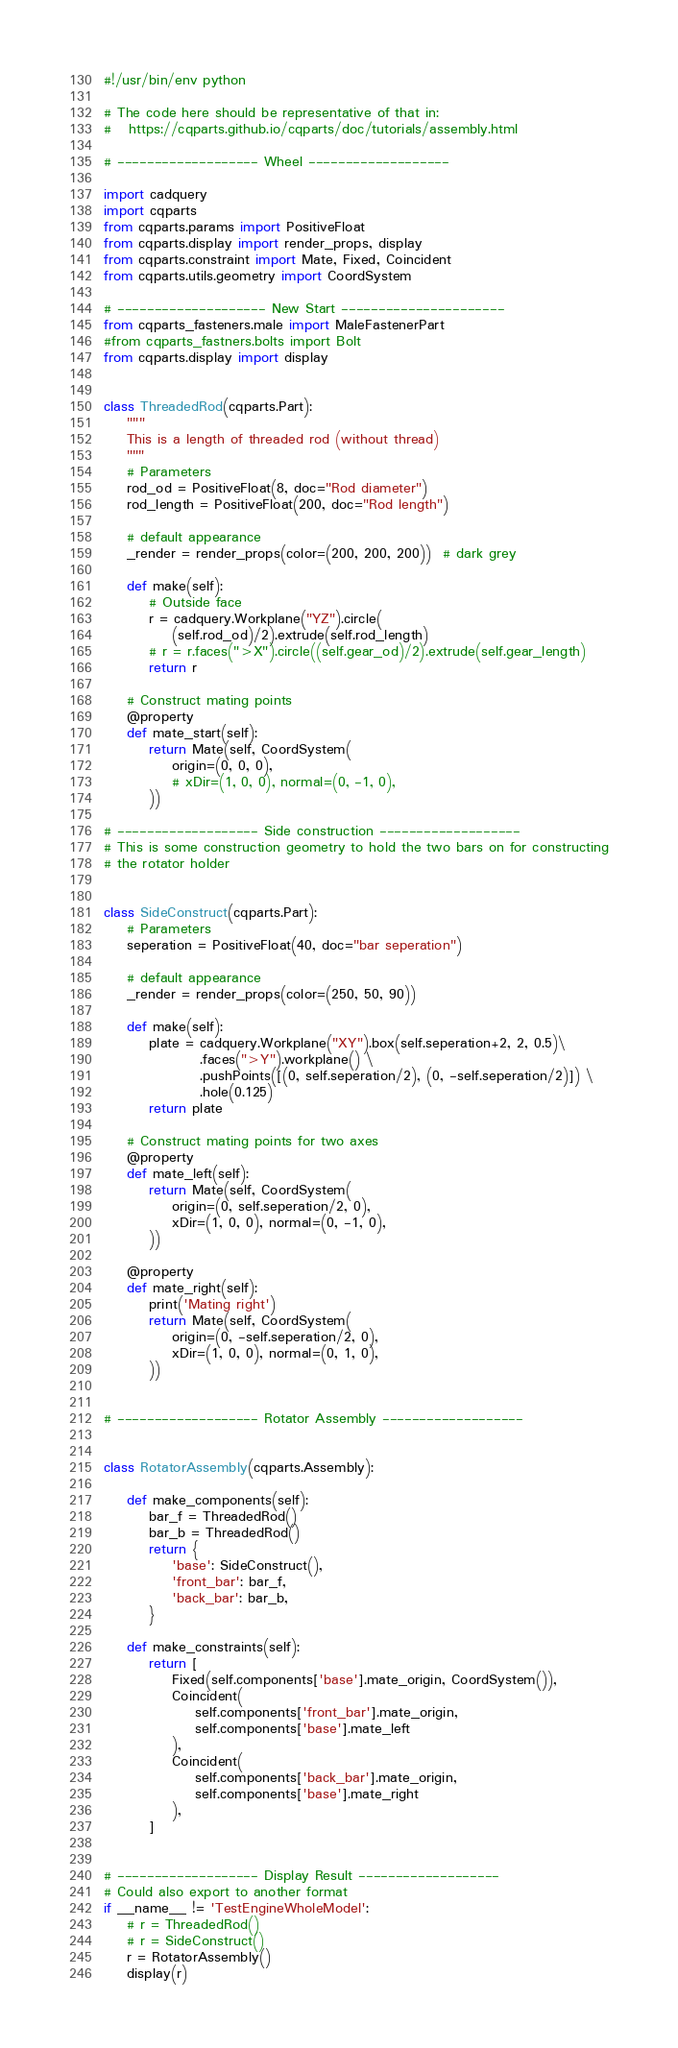Convert code to text. <code><loc_0><loc_0><loc_500><loc_500><_Python_>#!/usr/bin/env python

# The code here should be representative of that in:
#   https://cqparts.github.io/cqparts/doc/tutorials/assembly.html

# ------------------- Wheel -------------------

import cadquery
import cqparts
from cqparts.params import PositiveFloat
from cqparts.display import render_props, display
from cqparts.constraint import Mate, Fixed, Coincident
from cqparts.utils.geometry import CoordSystem

# -------------------- New Start ----------------------
from cqparts_fasteners.male import MaleFastenerPart
#from cqparts_fastners.bolts import Bolt
from cqparts.display import display


class ThreadedRod(cqparts.Part):
    """
    This is a length of threaded rod (without thread)
    """
    # Parameters
    rod_od = PositiveFloat(8, doc="Rod diameter")
    rod_length = PositiveFloat(200, doc="Rod length")

    # default appearance
    _render = render_props(color=(200, 200, 200))  # dark grey

    def make(self):
        # Outside face
        r = cadquery.Workplane("YZ").circle(
            (self.rod_od)/2).extrude(self.rod_length)
        # r = r.faces(">X").circle((self.gear_od)/2).extrude(self.gear_length)
        return r

    # Construct mating points
    @property
    def mate_start(self):
        return Mate(self, CoordSystem(
            origin=(0, 0, 0),
            # xDir=(1, 0, 0), normal=(0, -1, 0),
        ))

# ------------------- Side construction -------------------
# This is some construction geometry to hold the two bars on for constructing
# the rotator holder


class SideConstruct(cqparts.Part):
    # Parameters
    seperation = PositiveFloat(40, doc="bar seperation")

    # default appearance
    _render = render_props(color=(250, 50, 90))

    def make(self):
        plate = cadquery.Workplane("XY").box(self.seperation+2, 2, 0.5)\
                 .faces(">Y").workplane() \
                 .pushPoints([(0, self.seperation/2), (0, -self.seperation/2)]) \
                 .hole(0.125)
        return plate

    # Construct mating points for two axes
    @property
    def mate_left(self):
        return Mate(self, CoordSystem(
            origin=(0, self.seperation/2, 0),
            xDir=(1, 0, 0), normal=(0, -1, 0),
        ))

    @property
    def mate_right(self):
        print('Mating right')
        return Mate(self, CoordSystem(
            origin=(0, -self.seperation/2, 0),
            xDir=(1, 0, 0), normal=(0, 1, 0),
        ))


# ------------------- Rotator Assembly -------------------


class RotatorAssembly(cqparts.Assembly):

    def make_components(self):
        bar_f = ThreadedRod()
        bar_b = ThreadedRod()
        return {
            'base': SideConstruct(),
            'front_bar': bar_f,
            'back_bar': bar_b,
        }

    def make_constraints(self):
        return [
            Fixed(self.components['base'].mate_origin, CoordSystem()),
            Coincident(
                self.components['front_bar'].mate_origin,
                self.components['base'].mate_left
            ),
            Coincident(
                self.components['back_bar'].mate_origin,
                self.components['base'].mate_right
            ),
        ]


# ------------------- Display Result -------------------
# Could also export to another format
if __name__ != 'TestEngineWholeModel':
    # r = ThreadedRod()
    # r = SideConstruct()
    r = RotatorAssembly()
    display(r)
</code> 